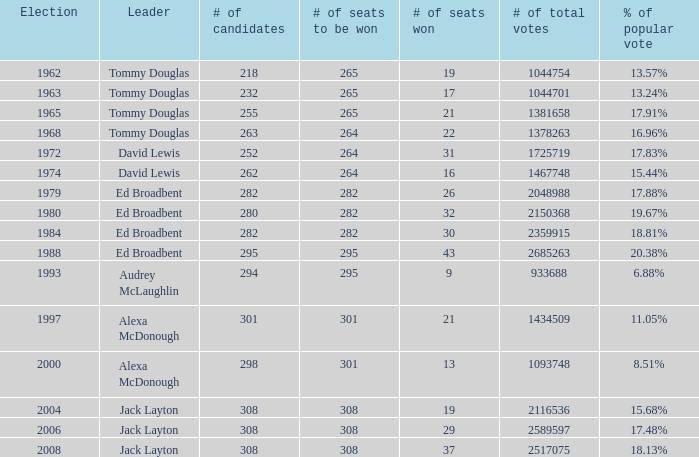Identify the quantity of leaders with 1 1.0. 